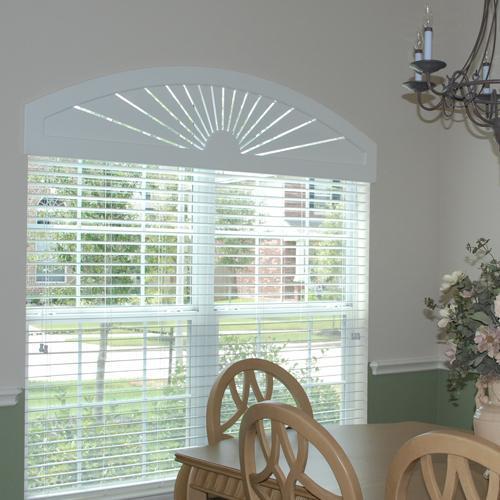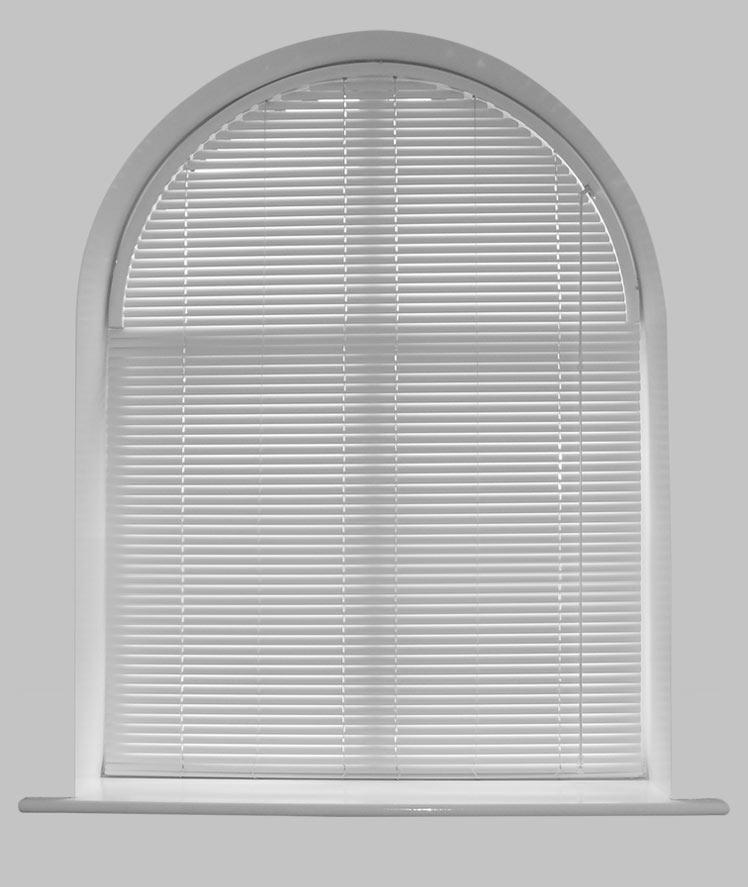The first image is the image on the left, the second image is the image on the right. For the images shown, is this caption "There is furniture visible in exactly one image." true? Answer yes or no. Yes. 